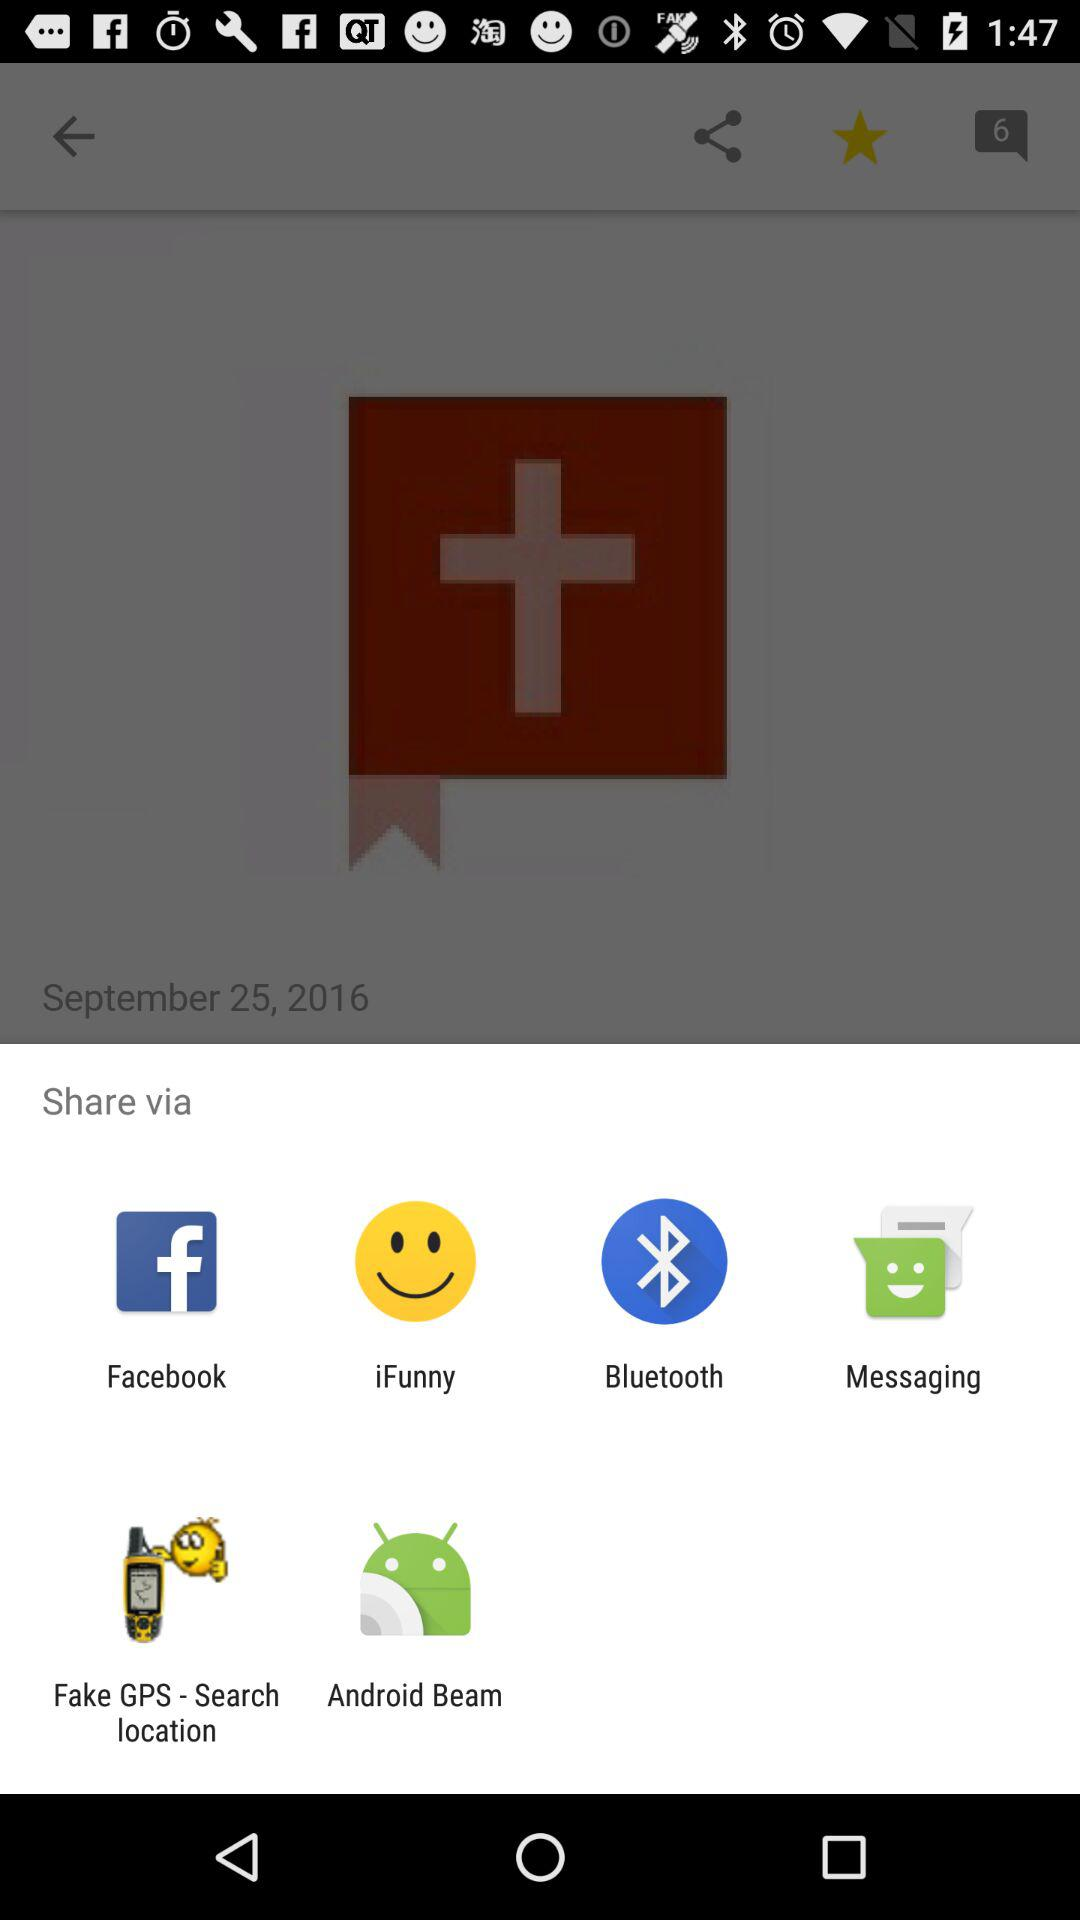What application chooses to share? The applications are "Facebook", "iFunny", "Bluetooth", "Messaging", "Fake GPS-Search location", and "Android Beam". 